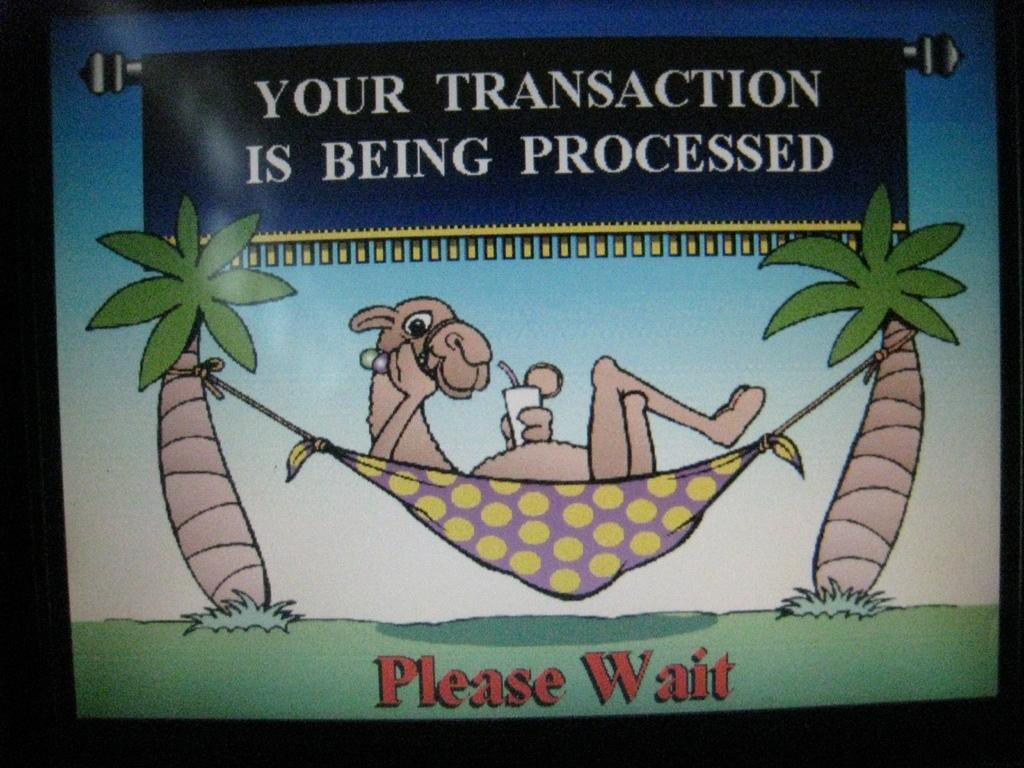What type of image is being described? The image is a cartoon. What animal is present in the cartoon? There is a camel in the image. What is the camel doing in the cartoon? The camel is sleeping. How is the camel covered in the cartoon? The camel is covered by a cloth. How is the camel secured in the cartoon? The camel is tied to two trees. How does the camel increase its speed while swimming in the image? There is no swimming or speed increase mentioned in the image; the camel is sleeping and tied to two trees. Can you tell me where the jellyfish is hiding in the image? There are no jellyfish present in the image; it features a cartoon camel sleeping and covered by a cloth. 